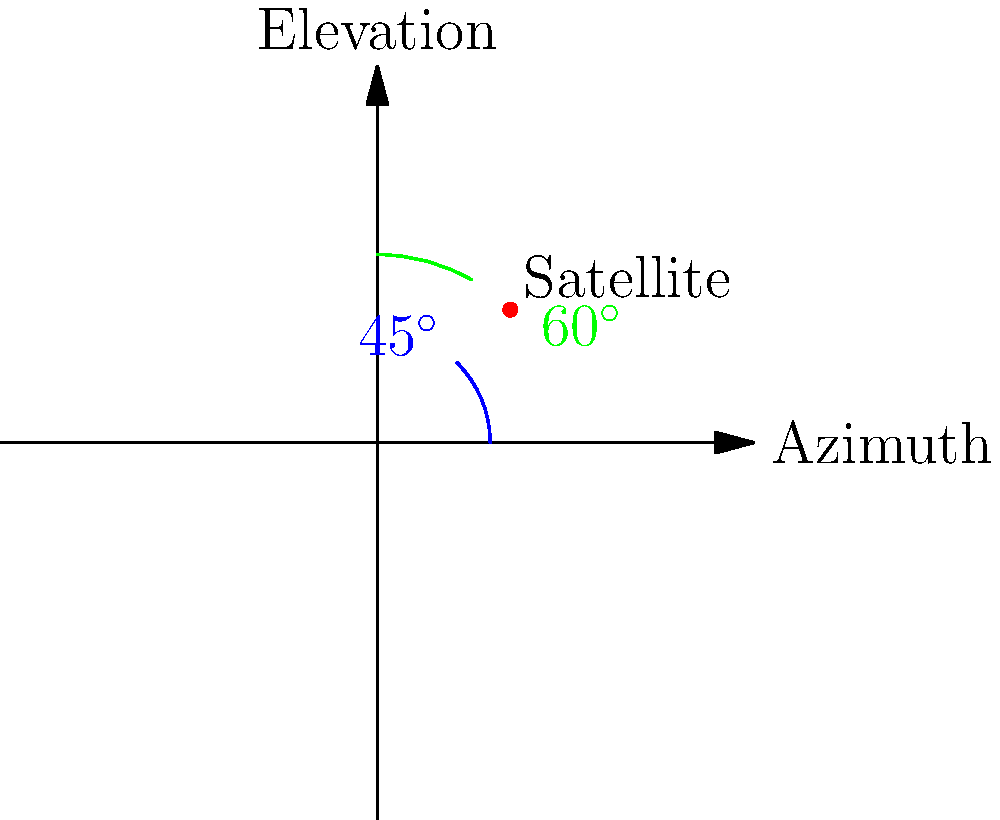Given a satellite's position in celestial coordinates with an azimuth of 45° and an elevation of 60°, calculate the optimal angle for a ground-based tracking antenna to maintain continuous communication. Assume the Earth is a perfect sphere and neglect atmospheric refraction. To determine the optimal angle for the ground-based tracking antenna, we need to follow these steps:

1. Understand the given coordinates:
   - Azimuth: $45^\circ$ (measured clockwise from north)
   - Elevation: $60^\circ$ (measured from the horizon)

2. Convert spherical coordinates to Cartesian coordinates:
   $x = \cos(\text{azimuth}) \cdot \cos(\text{elevation})$
   $y = \sin(\text{azimuth}) \cdot \cos(\text{elevation})$
   $z = \sin(\text{elevation})$

3. Calculate the components:
   $x = \cos(45^\circ) \cdot \cos(60^\circ) \approx 0.3536$
   $y = \sin(45^\circ) \cdot \cos(60^\circ) \approx 0.3536$
   $z = \sin(60^\circ) \approx 0.8660$

4. The optimal angle for the tracking antenna is the elevation angle from the ground to the satellite. This can be calculated using the arctangent function:

   $\theta = \arctan(\frac{z}{\sqrt{x^2 + y^2}})$

5. Substitute the values:
   $\theta = \arctan(\frac{0.8660}{\sqrt{0.3536^2 + 0.3536^2}})$

6. Simplify and calculate:
   $\theta = \arctan(\frac{0.8660}{0.5}) \approx 60^\circ$

The optimal angle for the ground-based tracking antenna is approximately 60° from the horizontal.
Answer: $60^\circ$ 